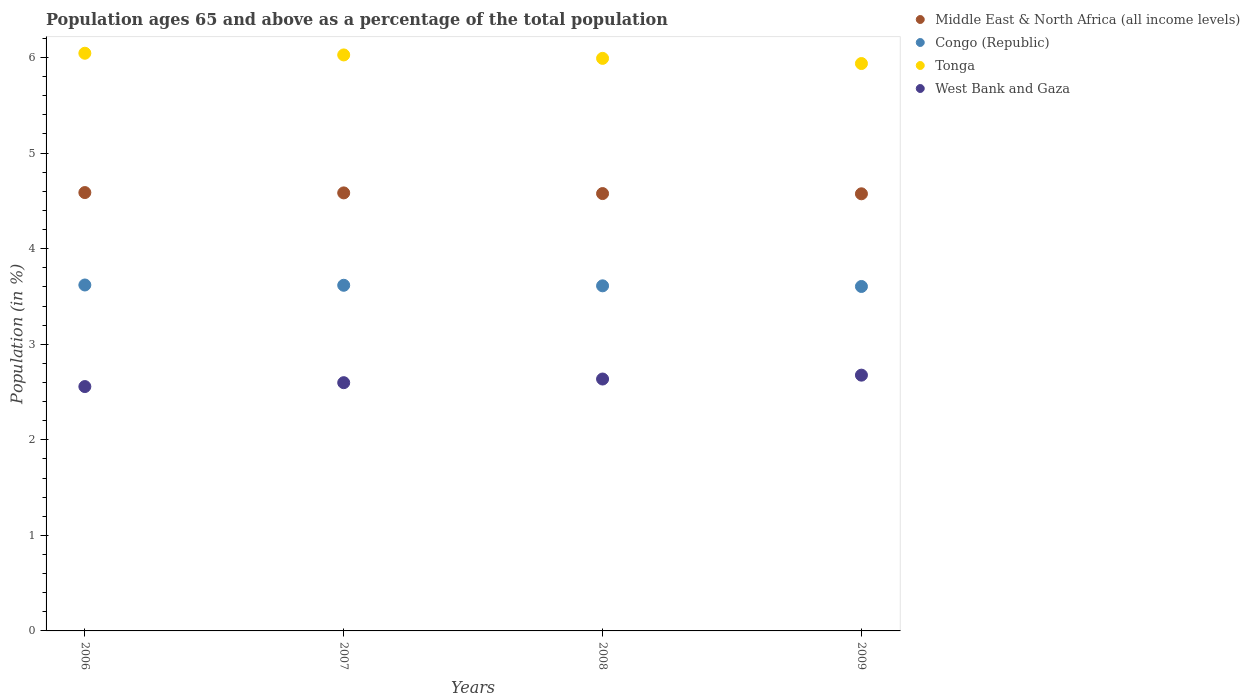What is the percentage of the population ages 65 and above in West Bank and Gaza in 2008?
Offer a terse response. 2.64. Across all years, what is the maximum percentage of the population ages 65 and above in Middle East & North Africa (all income levels)?
Your answer should be very brief. 4.59. Across all years, what is the minimum percentage of the population ages 65 and above in Middle East & North Africa (all income levels)?
Your answer should be compact. 4.57. In which year was the percentage of the population ages 65 and above in Congo (Republic) maximum?
Your answer should be compact. 2006. What is the total percentage of the population ages 65 and above in Middle East & North Africa (all income levels) in the graph?
Ensure brevity in your answer.  18.32. What is the difference between the percentage of the population ages 65 and above in Tonga in 2007 and that in 2008?
Your response must be concise. 0.04. What is the difference between the percentage of the population ages 65 and above in Congo (Republic) in 2009 and the percentage of the population ages 65 and above in Tonga in 2007?
Your answer should be very brief. -2.42. What is the average percentage of the population ages 65 and above in Congo (Republic) per year?
Your answer should be compact. 3.61. In the year 2009, what is the difference between the percentage of the population ages 65 and above in Tonga and percentage of the population ages 65 and above in Congo (Republic)?
Keep it short and to the point. 2.33. What is the ratio of the percentage of the population ages 65 and above in Middle East & North Africa (all income levels) in 2007 to that in 2008?
Provide a succinct answer. 1. What is the difference between the highest and the second highest percentage of the population ages 65 and above in Tonga?
Provide a succinct answer. 0.02. What is the difference between the highest and the lowest percentage of the population ages 65 and above in Tonga?
Your response must be concise. 0.11. In how many years, is the percentage of the population ages 65 and above in West Bank and Gaza greater than the average percentage of the population ages 65 and above in West Bank and Gaza taken over all years?
Keep it short and to the point. 2. Is the sum of the percentage of the population ages 65 and above in West Bank and Gaza in 2006 and 2009 greater than the maximum percentage of the population ages 65 and above in Congo (Republic) across all years?
Offer a terse response. Yes. Is it the case that in every year, the sum of the percentage of the population ages 65 and above in Middle East & North Africa (all income levels) and percentage of the population ages 65 and above in Congo (Republic)  is greater than the sum of percentage of the population ages 65 and above in Tonga and percentage of the population ages 65 and above in West Bank and Gaza?
Offer a terse response. Yes. Is it the case that in every year, the sum of the percentage of the population ages 65 and above in Tonga and percentage of the population ages 65 and above in Middle East & North Africa (all income levels)  is greater than the percentage of the population ages 65 and above in West Bank and Gaza?
Provide a succinct answer. Yes. Does the percentage of the population ages 65 and above in Congo (Republic) monotonically increase over the years?
Offer a very short reply. No. Is the percentage of the population ages 65 and above in Tonga strictly greater than the percentage of the population ages 65 and above in Congo (Republic) over the years?
Ensure brevity in your answer.  Yes. Is the percentage of the population ages 65 and above in Tonga strictly less than the percentage of the population ages 65 and above in West Bank and Gaza over the years?
Make the answer very short. No. How many dotlines are there?
Ensure brevity in your answer.  4. How many years are there in the graph?
Offer a terse response. 4. Are the values on the major ticks of Y-axis written in scientific E-notation?
Your answer should be compact. No. How many legend labels are there?
Your response must be concise. 4. What is the title of the graph?
Offer a terse response. Population ages 65 and above as a percentage of the total population. What is the label or title of the Y-axis?
Keep it short and to the point. Population (in %). What is the Population (in %) of Middle East & North Africa (all income levels) in 2006?
Your response must be concise. 4.59. What is the Population (in %) in Congo (Republic) in 2006?
Ensure brevity in your answer.  3.62. What is the Population (in %) of Tonga in 2006?
Your answer should be compact. 6.04. What is the Population (in %) of West Bank and Gaza in 2006?
Offer a terse response. 2.56. What is the Population (in %) of Middle East & North Africa (all income levels) in 2007?
Ensure brevity in your answer.  4.58. What is the Population (in %) in Congo (Republic) in 2007?
Your response must be concise. 3.62. What is the Population (in %) in Tonga in 2007?
Your answer should be compact. 6.03. What is the Population (in %) in West Bank and Gaza in 2007?
Provide a short and direct response. 2.6. What is the Population (in %) in Middle East & North Africa (all income levels) in 2008?
Your response must be concise. 4.58. What is the Population (in %) of Congo (Republic) in 2008?
Give a very brief answer. 3.61. What is the Population (in %) in Tonga in 2008?
Your answer should be compact. 5.99. What is the Population (in %) of West Bank and Gaza in 2008?
Provide a succinct answer. 2.64. What is the Population (in %) in Middle East & North Africa (all income levels) in 2009?
Offer a very short reply. 4.57. What is the Population (in %) of Congo (Republic) in 2009?
Offer a very short reply. 3.6. What is the Population (in %) in Tonga in 2009?
Ensure brevity in your answer.  5.94. What is the Population (in %) of West Bank and Gaza in 2009?
Give a very brief answer. 2.68. Across all years, what is the maximum Population (in %) of Middle East & North Africa (all income levels)?
Make the answer very short. 4.59. Across all years, what is the maximum Population (in %) of Congo (Republic)?
Provide a short and direct response. 3.62. Across all years, what is the maximum Population (in %) of Tonga?
Your answer should be very brief. 6.04. Across all years, what is the maximum Population (in %) of West Bank and Gaza?
Make the answer very short. 2.68. Across all years, what is the minimum Population (in %) in Middle East & North Africa (all income levels)?
Your answer should be very brief. 4.57. Across all years, what is the minimum Population (in %) in Congo (Republic)?
Your answer should be compact. 3.6. Across all years, what is the minimum Population (in %) in Tonga?
Offer a terse response. 5.94. Across all years, what is the minimum Population (in %) of West Bank and Gaza?
Your answer should be very brief. 2.56. What is the total Population (in %) of Middle East & North Africa (all income levels) in the graph?
Offer a very short reply. 18.32. What is the total Population (in %) in Congo (Republic) in the graph?
Your answer should be compact. 14.45. What is the total Population (in %) of Tonga in the graph?
Offer a very short reply. 24. What is the total Population (in %) of West Bank and Gaza in the graph?
Your answer should be very brief. 10.47. What is the difference between the Population (in %) of Middle East & North Africa (all income levels) in 2006 and that in 2007?
Offer a very short reply. 0. What is the difference between the Population (in %) of Congo (Republic) in 2006 and that in 2007?
Your answer should be very brief. 0. What is the difference between the Population (in %) of Tonga in 2006 and that in 2007?
Ensure brevity in your answer.  0.02. What is the difference between the Population (in %) in West Bank and Gaza in 2006 and that in 2007?
Make the answer very short. -0.04. What is the difference between the Population (in %) of Middle East & North Africa (all income levels) in 2006 and that in 2008?
Your answer should be compact. 0.01. What is the difference between the Population (in %) in Congo (Republic) in 2006 and that in 2008?
Ensure brevity in your answer.  0.01. What is the difference between the Population (in %) of Tonga in 2006 and that in 2008?
Your answer should be very brief. 0.05. What is the difference between the Population (in %) of West Bank and Gaza in 2006 and that in 2008?
Your response must be concise. -0.08. What is the difference between the Population (in %) in Middle East & North Africa (all income levels) in 2006 and that in 2009?
Your response must be concise. 0.01. What is the difference between the Population (in %) in Congo (Republic) in 2006 and that in 2009?
Give a very brief answer. 0.02. What is the difference between the Population (in %) of Tonga in 2006 and that in 2009?
Provide a short and direct response. 0.11. What is the difference between the Population (in %) of West Bank and Gaza in 2006 and that in 2009?
Provide a short and direct response. -0.12. What is the difference between the Population (in %) in Middle East & North Africa (all income levels) in 2007 and that in 2008?
Your response must be concise. 0.01. What is the difference between the Population (in %) of Congo (Republic) in 2007 and that in 2008?
Ensure brevity in your answer.  0.01. What is the difference between the Population (in %) of Tonga in 2007 and that in 2008?
Give a very brief answer. 0.04. What is the difference between the Population (in %) in West Bank and Gaza in 2007 and that in 2008?
Make the answer very short. -0.04. What is the difference between the Population (in %) of Middle East & North Africa (all income levels) in 2007 and that in 2009?
Make the answer very short. 0.01. What is the difference between the Population (in %) in Congo (Republic) in 2007 and that in 2009?
Make the answer very short. 0.01. What is the difference between the Population (in %) of Tonga in 2007 and that in 2009?
Your response must be concise. 0.09. What is the difference between the Population (in %) in West Bank and Gaza in 2007 and that in 2009?
Make the answer very short. -0.08. What is the difference between the Population (in %) in Middle East & North Africa (all income levels) in 2008 and that in 2009?
Keep it short and to the point. 0. What is the difference between the Population (in %) of Congo (Republic) in 2008 and that in 2009?
Give a very brief answer. 0.01. What is the difference between the Population (in %) in Tonga in 2008 and that in 2009?
Make the answer very short. 0.05. What is the difference between the Population (in %) in West Bank and Gaza in 2008 and that in 2009?
Provide a short and direct response. -0.04. What is the difference between the Population (in %) in Middle East & North Africa (all income levels) in 2006 and the Population (in %) in Congo (Republic) in 2007?
Your answer should be compact. 0.97. What is the difference between the Population (in %) of Middle East & North Africa (all income levels) in 2006 and the Population (in %) of Tonga in 2007?
Provide a short and direct response. -1.44. What is the difference between the Population (in %) of Middle East & North Africa (all income levels) in 2006 and the Population (in %) of West Bank and Gaza in 2007?
Offer a terse response. 1.99. What is the difference between the Population (in %) in Congo (Republic) in 2006 and the Population (in %) in Tonga in 2007?
Your answer should be very brief. -2.41. What is the difference between the Population (in %) of Congo (Republic) in 2006 and the Population (in %) of West Bank and Gaza in 2007?
Your answer should be compact. 1.02. What is the difference between the Population (in %) in Tonga in 2006 and the Population (in %) in West Bank and Gaza in 2007?
Offer a terse response. 3.45. What is the difference between the Population (in %) of Middle East & North Africa (all income levels) in 2006 and the Population (in %) of Congo (Republic) in 2008?
Ensure brevity in your answer.  0.98. What is the difference between the Population (in %) of Middle East & North Africa (all income levels) in 2006 and the Population (in %) of Tonga in 2008?
Your response must be concise. -1.4. What is the difference between the Population (in %) in Middle East & North Africa (all income levels) in 2006 and the Population (in %) in West Bank and Gaza in 2008?
Keep it short and to the point. 1.95. What is the difference between the Population (in %) in Congo (Republic) in 2006 and the Population (in %) in Tonga in 2008?
Provide a succinct answer. -2.37. What is the difference between the Population (in %) of Tonga in 2006 and the Population (in %) of West Bank and Gaza in 2008?
Make the answer very short. 3.41. What is the difference between the Population (in %) in Middle East & North Africa (all income levels) in 2006 and the Population (in %) in Congo (Republic) in 2009?
Provide a succinct answer. 0.98. What is the difference between the Population (in %) in Middle East & North Africa (all income levels) in 2006 and the Population (in %) in Tonga in 2009?
Ensure brevity in your answer.  -1.35. What is the difference between the Population (in %) of Middle East & North Africa (all income levels) in 2006 and the Population (in %) of West Bank and Gaza in 2009?
Offer a terse response. 1.91. What is the difference between the Population (in %) in Congo (Republic) in 2006 and the Population (in %) in Tonga in 2009?
Your response must be concise. -2.32. What is the difference between the Population (in %) of Congo (Republic) in 2006 and the Population (in %) of West Bank and Gaza in 2009?
Your answer should be compact. 0.94. What is the difference between the Population (in %) of Tonga in 2006 and the Population (in %) of West Bank and Gaza in 2009?
Ensure brevity in your answer.  3.37. What is the difference between the Population (in %) in Middle East & North Africa (all income levels) in 2007 and the Population (in %) in Congo (Republic) in 2008?
Your answer should be compact. 0.97. What is the difference between the Population (in %) in Middle East & North Africa (all income levels) in 2007 and the Population (in %) in Tonga in 2008?
Ensure brevity in your answer.  -1.41. What is the difference between the Population (in %) in Middle East & North Africa (all income levels) in 2007 and the Population (in %) in West Bank and Gaza in 2008?
Offer a very short reply. 1.95. What is the difference between the Population (in %) in Congo (Republic) in 2007 and the Population (in %) in Tonga in 2008?
Make the answer very short. -2.37. What is the difference between the Population (in %) of Congo (Republic) in 2007 and the Population (in %) of West Bank and Gaza in 2008?
Give a very brief answer. 0.98. What is the difference between the Population (in %) of Tonga in 2007 and the Population (in %) of West Bank and Gaza in 2008?
Provide a succinct answer. 3.39. What is the difference between the Population (in %) in Middle East & North Africa (all income levels) in 2007 and the Population (in %) in Congo (Republic) in 2009?
Offer a terse response. 0.98. What is the difference between the Population (in %) in Middle East & North Africa (all income levels) in 2007 and the Population (in %) in Tonga in 2009?
Your response must be concise. -1.35. What is the difference between the Population (in %) in Middle East & North Africa (all income levels) in 2007 and the Population (in %) in West Bank and Gaza in 2009?
Offer a very short reply. 1.91. What is the difference between the Population (in %) in Congo (Republic) in 2007 and the Population (in %) in Tonga in 2009?
Ensure brevity in your answer.  -2.32. What is the difference between the Population (in %) in Congo (Republic) in 2007 and the Population (in %) in West Bank and Gaza in 2009?
Offer a very short reply. 0.94. What is the difference between the Population (in %) in Tonga in 2007 and the Population (in %) in West Bank and Gaza in 2009?
Provide a succinct answer. 3.35. What is the difference between the Population (in %) in Middle East & North Africa (all income levels) in 2008 and the Population (in %) in Congo (Republic) in 2009?
Offer a terse response. 0.97. What is the difference between the Population (in %) of Middle East & North Africa (all income levels) in 2008 and the Population (in %) of Tonga in 2009?
Your response must be concise. -1.36. What is the difference between the Population (in %) of Middle East & North Africa (all income levels) in 2008 and the Population (in %) of West Bank and Gaza in 2009?
Your answer should be compact. 1.9. What is the difference between the Population (in %) of Congo (Republic) in 2008 and the Population (in %) of Tonga in 2009?
Keep it short and to the point. -2.33. What is the difference between the Population (in %) in Congo (Republic) in 2008 and the Population (in %) in West Bank and Gaza in 2009?
Provide a succinct answer. 0.93. What is the difference between the Population (in %) in Tonga in 2008 and the Population (in %) in West Bank and Gaza in 2009?
Give a very brief answer. 3.31. What is the average Population (in %) in Middle East & North Africa (all income levels) per year?
Provide a succinct answer. 4.58. What is the average Population (in %) of Congo (Republic) per year?
Offer a very short reply. 3.61. What is the average Population (in %) of Tonga per year?
Give a very brief answer. 6. What is the average Population (in %) of West Bank and Gaza per year?
Provide a short and direct response. 2.62. In the year 2006, what is the difference between the Population (in %) in Middle East & North Africa (all income levels) and Population (in %) in Congo (Republic)?
Keep it short and to the point. 0.97. In the year 2006, what is the difference between the Population (in %) in Middle East & North Africa (all income levels) and Population (in %) in Tonga?
Make the answer very short. -1.46. In the year 2006, what is the difference between the Population (in %) in Middle East & North Africa (all income levels) and Population (in %) in West Bank and Gaza?
Offer a terse response. 2.03. In the year 2006, what is the difference between the Population (in %) of Congo (Republic) and Population (in %) of Tonga?
Give a very brief answer. -2.43. In the year 2006, what is the difference between the Population (in %) in Congo (Republic) and Population (in %) in West Bank and Gaza?
Your answer should be very brief. 1.06. In the year 2006, what is the difference between the Population (in %) in Tonga and Population (in %) in West Bank and Gaza?
Keep it short and to the point. 3.49. In the year 2007, what is the difference between the Population (in %) in Middle East & North Africa (all income levels) and Population (in %) in Congo (Republic)?
Your response must be concise. 0.97. In the year 2007, what is the difference between the Population (in %) in Middle East & North Africa (all income levels) and Population (in %) in Tonga?
Your answer should be very brief. -1.44. In the year 2007, what is the difference between the Population (in %) of Middle East & North Africa (all income levels) and Population (in %) of West Bank and Gaza?
Offer a terse response. 1.99. In the year 2007, what is the difference between the Population (in %) of Congo (Republic) and Population (in %) of Tonga?
Provide a short and direct response. -2.41. In the year 2007, what is the difference between the Population (in %) in Congo (Republic) and Population (in %) in West Bank and Gaza?
Offer a terse response. 1.02. In the year 2007, what is the difference between the Population (in %) of Tonga and Population (in %) of West Bank and Gaza?
Make the answer very short. 3.43. In the year 2008, what is the difference between the Population (in %) in Middle East & North Africa (all income levels) and Population (in %) in Congo (Republic)?
Provide a short and direct response. 0.97. In the year 2008, what is the difference between the Population (in %) of Middle East & North Africa (all income levels) and Population (in %) of Tonga?
Provide a succinct answer. -1.41. In the year 2008, what is the difference between the Population (in %) in Middle East & North Africa (all income levels) and Population (in %) in West Bank and Gaza?
Your answer should be very brief. 1.94. In the year 2008, what is the difference between the Population (in %) in Congo (Republic) and Population (in %) in Tonga?
Provide a short and direct response. -2.38. In the year 2008, what is the difference between the Population (in %) in Congo (Republic) and Population (in %) in West Bank and Gaza?
Your answer should be compact. 0.98. In the year 2008, what is the difference between the Population (in %) of Tonga and Population (in %) of West Bank and Gaza?
Your answer should be compact. 3.36. In the year 2009, what is the difference between the Population (in %) of Middle East & North Africa (all income levels) and Population (in %) of Congo (Republic)?
Your answer should be very brief. 0.97. In the year 2009, what is the difference between the Population (in %) of Middle East & North Africa (all income levels) and Population (in %) of Tonga?
Offer a terse response. -1.36. In the year 2009, what is the difference between the Population (in %) in Middle East & North Africa (all income levels) and Population (in %) in West Bank and Gaza?
Provide a short and direct response. 1.9. In the year 2009, what is the difference between the Population (in %) in Congo (Republic) and Population (in %) in Tonga?
Provide a short and direct response. -2.33. In the year 2009, what is the difference between the Population (in %) of Congo (Republic) and Population (in %) of West Bank and Gaza?
Make the answer very short. 0.93. In the year 2009, what is the difference between the Population (in %) in Tonga and Population (in %) in West Bank and Gaza?
Keep it short and to the point. 3.26. What is the ratio of the Population (in %) of Middle East & North Africa (all income levels) in 2006 to that in 2007?
Offer a very short reply. 1. What is the ratio of the Population (in %) in Tonga in 2006 to that in 2007?
Ensure brevity in your answer.  1. What is the ratio of the Population (in %) in West Bank and Gaza in 2006 to that in 2007?
Provide a succinct answer. 0.98. What is the ratio of the Population (in %) of Tonga in 2006 to that in 2008?
Your answer should be compact. 1.01. What is the ratio of the Population (in %) of West Bank and Gaza in 2006 to that in 2008?
Ensure brevity in your answer.  0.97. What is the ratio of the Population (in %) in Middle East & North Africa (all income levels) in 2006 to that in 2009?
Make the answer very short. 1. What is the ratio of the Population (in %) of Congo (Republic) in 2006 to that in 2009?
Provide a succinct answer. 1. What is the ratio of the Population (in %) of Tonga in 2006 to that in 2009?
Give a very brief answer. 1.02. What is the ratio of the Population (in %) of West Bank and Gaza in 2006 to that in 2009?
Your answer should be compact. 0.96. What is the ratio of the Population (in %) of Tonga in 2007 to that in 2008?
Offer a very short reply. 1.01. What is the ratio of the Population (in %) in West Bank and Gaza in 2007 to that in 2008?
Give a very brief answer. 0.99. What is the ratio of the Population (in %) of Congo (Republic) in 2007 to that in 2009?
Provide a short and direct response. 1. What is the ratio of the Population (in %) of Tonga in 2007 to that in 2009?
Give a very brief answer. 1.02. What is the ratio of the Population (in %) in West Bank and Gaza in 2007 to that in 2009?
Make the answer very short. 0.97. What is the ratio of the Population (in %) of Congo (Republic) in 2008 to that in 2009?
Your answer should be very brief. 1. What is the ratio of the Population (in %) of Tonga in 2008 to that in 2009?
Give a very brief answer. 1.01. What is the ratio of the Population (in %) of West Bank and Gaza in 2008 to that in 2009?
Give a very brief answer. 0.98. What is the difference between the highest and the second highest Population (in %) of Middle East & North Africa (all income levels)?
Offer a very short reply. 0. What is the difference between the highest and the second highest Population (in %) in Congo (Republic)?
Ensure brevity in your answer.  0. What is the difference between the highest and the second highest Population (in %) in Tonga?
Give a very brief answer. 0.02. What is the difference between the highest and the second highest Population (in %) of West Bank and Gaza?
Your answer should be compact. 0.04. What is the difference between the highest and the lowest Population (in %) of Middle East & North Africa (all income levels)?
Your answer should be very brief. 0.01. What is the difference between the highest and the lowest Population (in %) in Congo (Republic)?
Your response must be concise. 0.02. What is the difference between the highest and the lowest Population (in %) in Tonga?
Make the answer very short. 0.11. What is the difference between the highest and the lowest Population (in %) of West Bank and Gaza?
Your response must be concise. 0.12. 